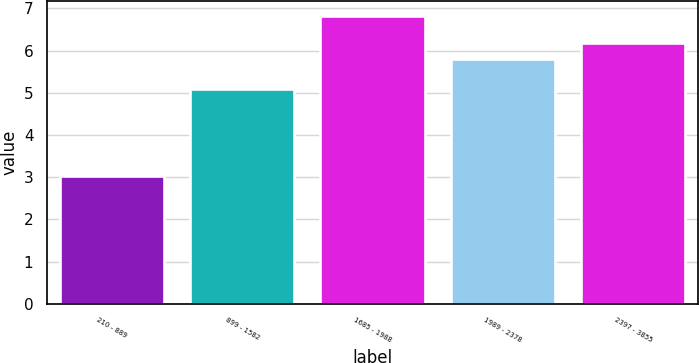Convert chart. <chart><loc_0><loc_0><loc_500><loc_500><bar_chart><fcel>210 - 889<fcel>899 - 1582<fcel>1685 - 1988<fcel>1989 - 2378<fcel>2397 - 3855<nl><fcel>3.03<fcel>5.1<fcel>6.83<fcel>5.8<fcel>6.18<nl></chart> 